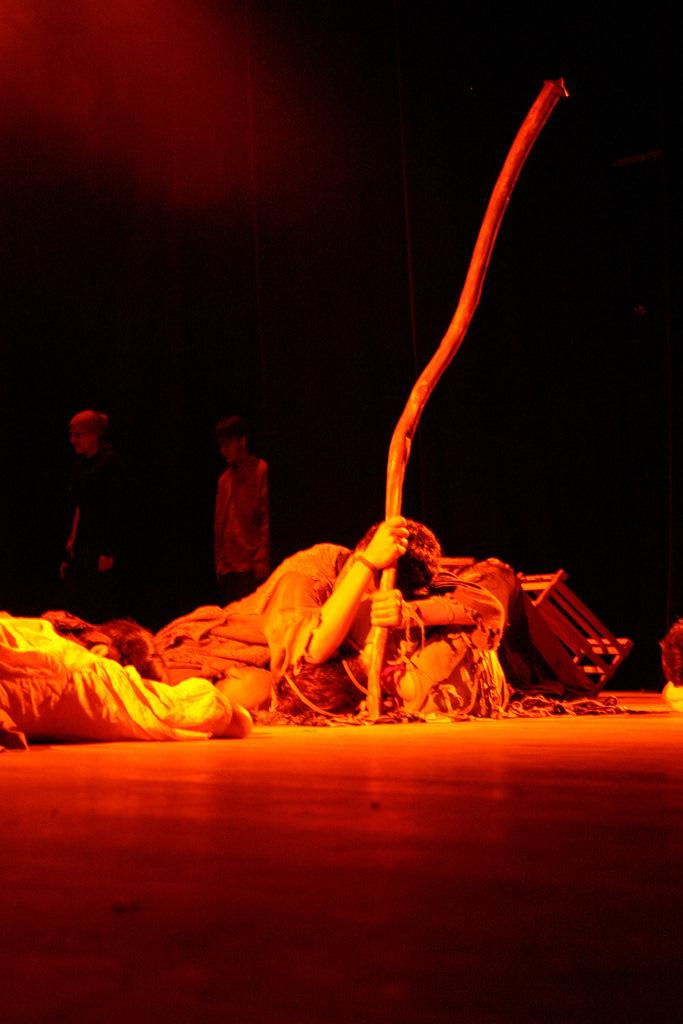What is the person in the foreground of the image holding? The person is holding a stick in the image. Can you describe the other people in the image? There are two other persons standing in the background of the image. What type of spiders can be seen crawling on the stick in the image? There are no spiders present in the image, and the stick is not being used by any spiders. 